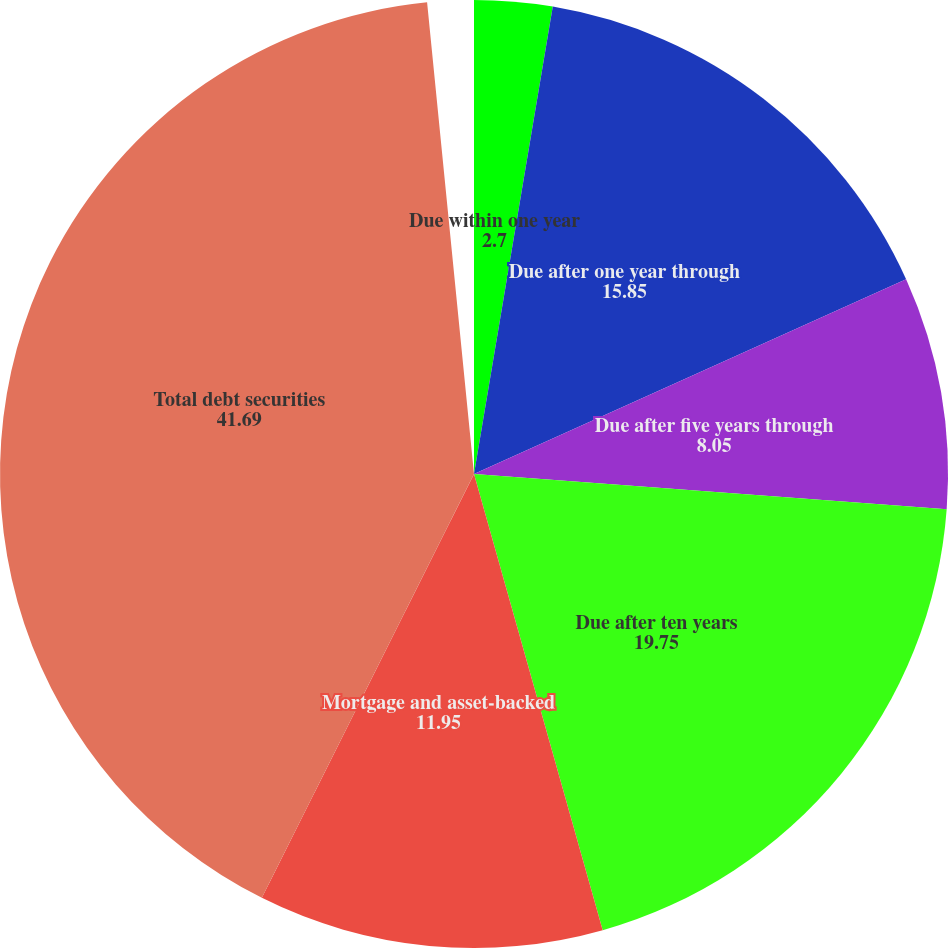Convert chart to OTSL. <chart><loc_0><loc_0><loc_500><loc_500><pie_chart><fcel>Due within one year<fcel>Due after one year through<fcel>Due after five years through<fcel>Due after ten years<fcel>Mortgage and asset-backed<fcel>Total debt securities<nl><fcel>2.7%<fcel>15.85%<fcel>8.05%<fcel>19.75%<fcel>11.95%<fcel>41.69%<nl></chart> 